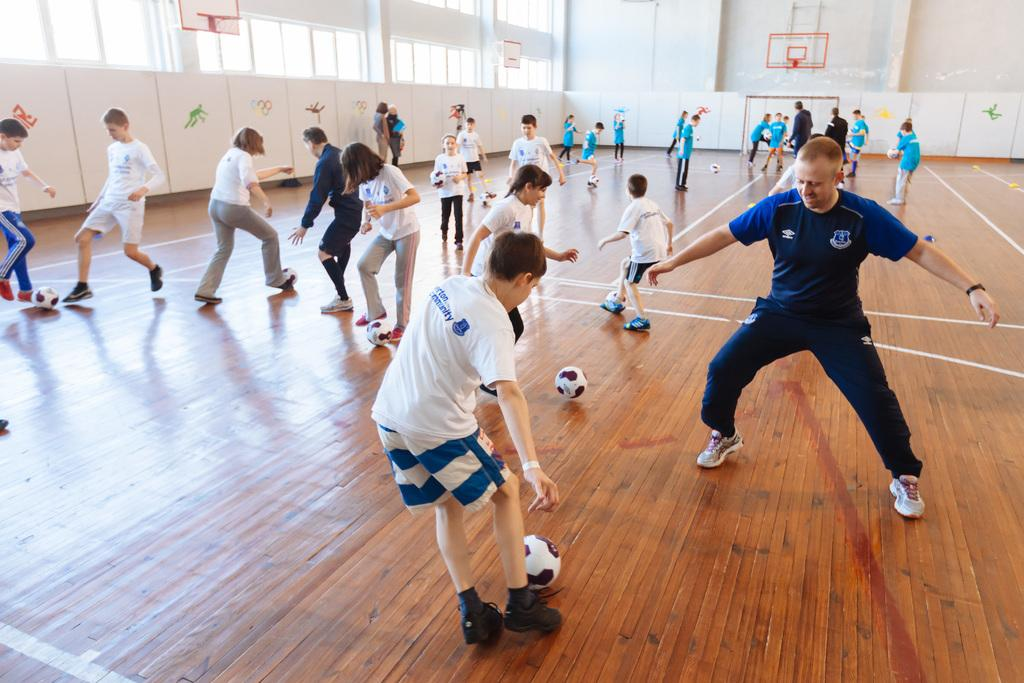What type of structure can be seen in the image? There are walls in the image, suggesting a building or room. What feature allows light and air into the space? There are windows in the image. Who or what is present in the image? There are people in the image. What type of flooring is visible in the image? There is a wooden floor in the image. What objects are being used by the people in the image? There are balls in the image, and some people are playing with them. How many basketball hoops are in the image? There are three basketball hoops in the image. What else can be seen in the image besides the people and basketball hoops? There are objects in the image, which could include other sports equipment or furniture. What type of silk fabric is draped over the door in the image? There is no door or silk fabric present in the image. How does the profit from the game being played in the image affect the players? There is no indication of a game being played for profit in the image, nor is there any information about the players' financial situation. 